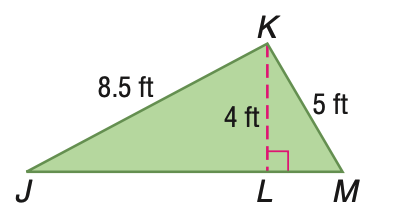Question: Find the area of \triangle J K M.
Choices:
A. 21
B. 21.25
C. 42
D. 42.5
Answer with the letter. Answer: A 